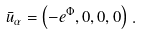Convert formula to latex. <formula><loc_0><loc_0><loc_500><loc_500>\bar { u } _ { \alpha } = \left ( - e ^ { \Phi } , 0 , 0 , 0 \right ) \, .</formula> 